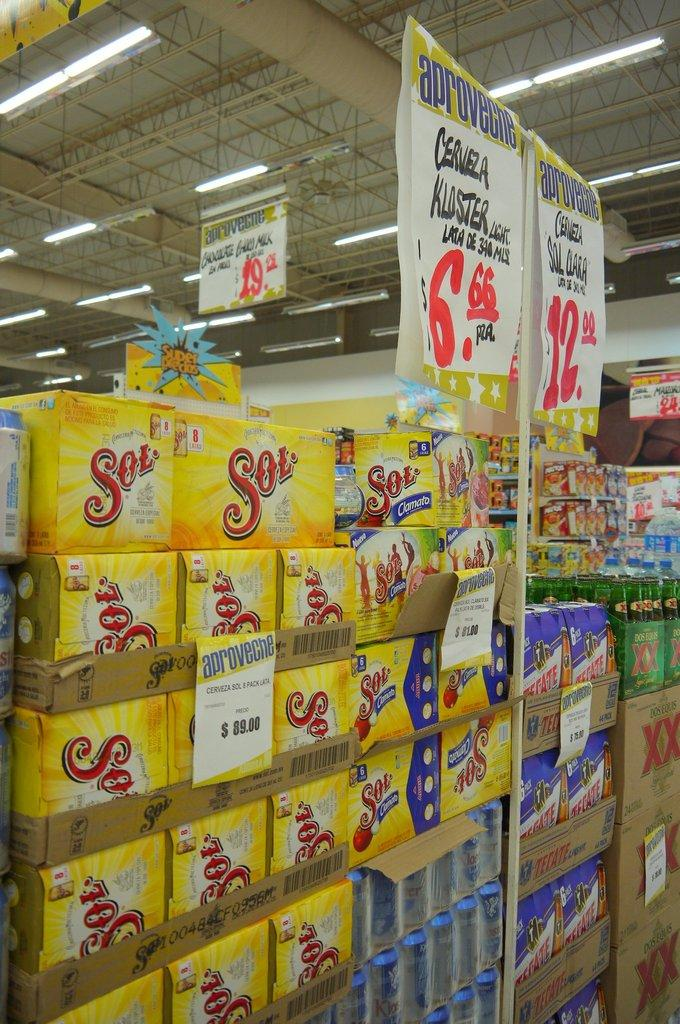<image>
Relay a brief, clear account of the picture shown. Boxes of Cerveza Sol 8 pack are sold in a store. 